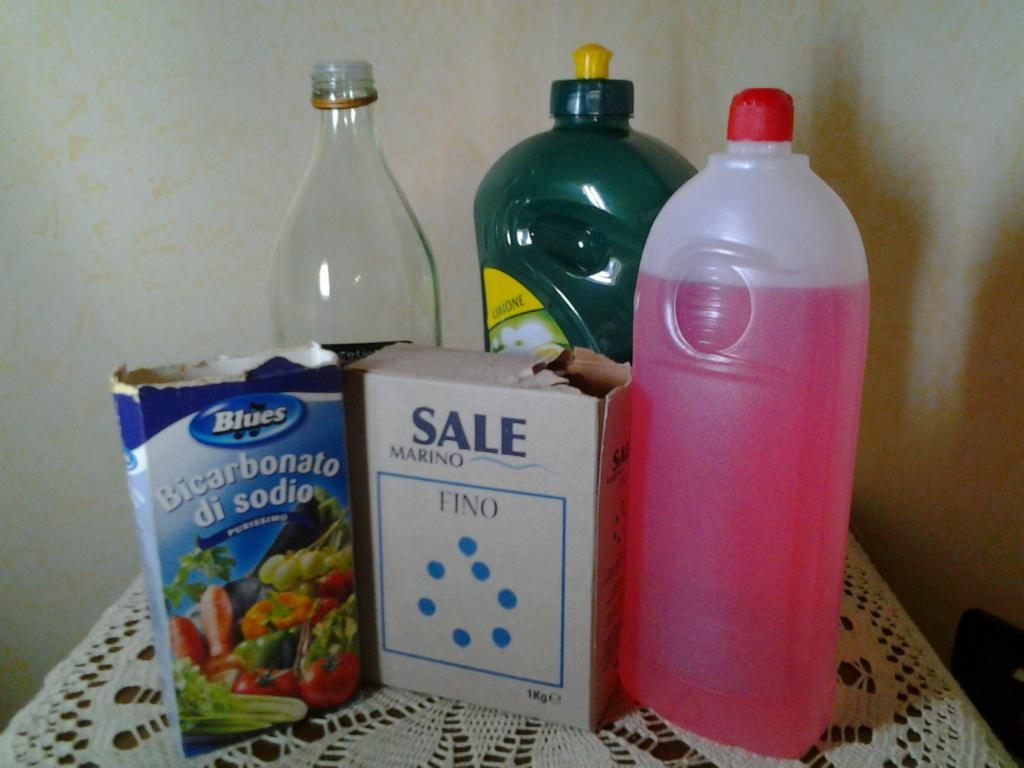Where was the image taken? The image was taken in a room. What furniture is present in the room? There is a table in the room. What items are on the table? There are boxes and a bottle on the table. What is behind the bottle on the table? There is a wall behind the bottle. What type of ice can be seen melting on the table in the image? There is no ice present in the image; it only features boxes, a bottle, and a wall. 